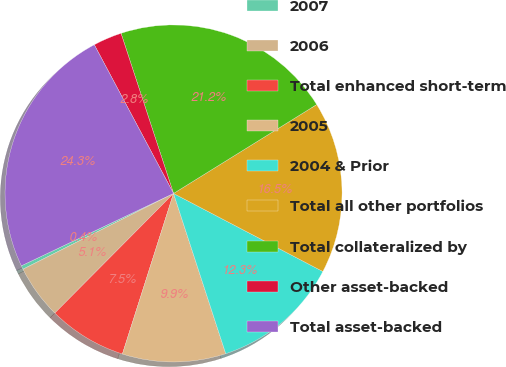<chart> <loc_0><loc_0><loc_500><loc_500><pie_chart><fcel>2007<fcel>2006<fcel>Total enhanced short-term<fcel>2005<fcel>2004 & Prior<fcel>Total all other portfolios<fcel>Total collateralized by<fcel>Other asset-backed<fcel>Total asset-backed<nl><fcel>0.36%<fcel>5.14%<fcel>7.53%<fcel>9.92%<fcel>12.32%<fcel>16.51%<fcel>21.2%<fcel>2.75%<fcel>24.27%<nl></chart> 